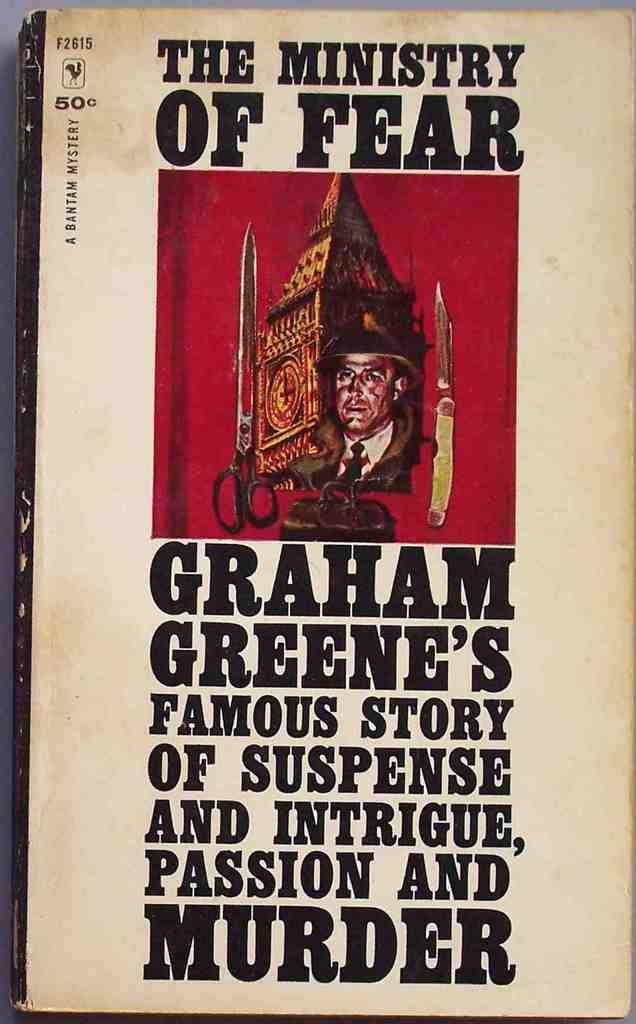<image>
Describe the image concisely. The cover of The Ministry of Fear depicting a picture of a man with weapons and the description of Graham Green's famous story of suspense and intrigue, passion and murder. 